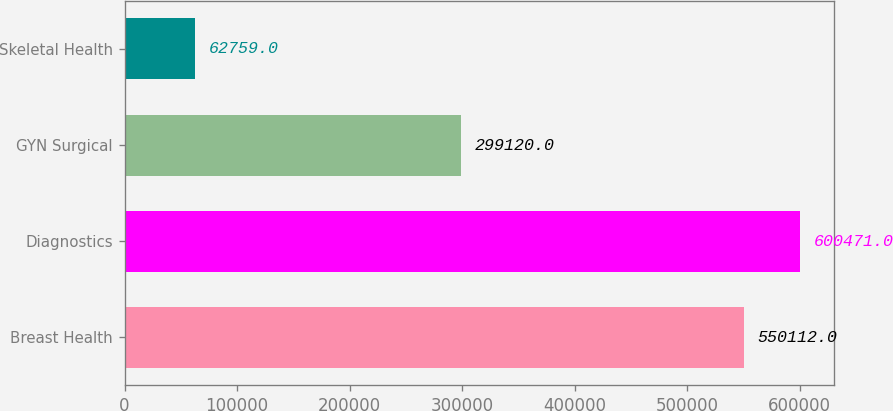<chart> <loc_0><loc_0><loc_500><loc_500><bar_chart><fcel>Breast Health<fcel>Diagnostics<fcel>GYN Surgical<fcel>Skeletal Health<nl><fcel>550112<fcel>600471<fcel>299120<fcel>62759<nl></chart> 